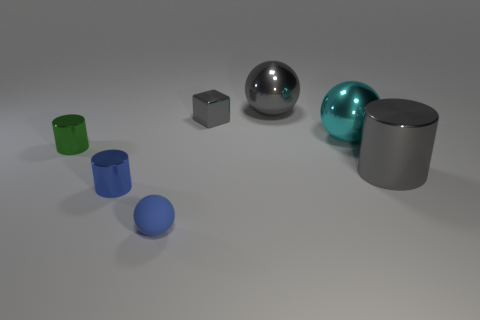Add 3 small blue matte spheres. How many objects exist? 10 Subtract all balls. How many objects are left? 4 Subtract all matte things. Subtract all small green shiny objects. How many objects are left? 5 Add 5 blue rubber balls. How many blue rubber balls are left? 6 Add 1 green rubber cylinders. How many green rubber cylinders exist? 1 Subtract 0 purple spheres. How many objects are left? 7 